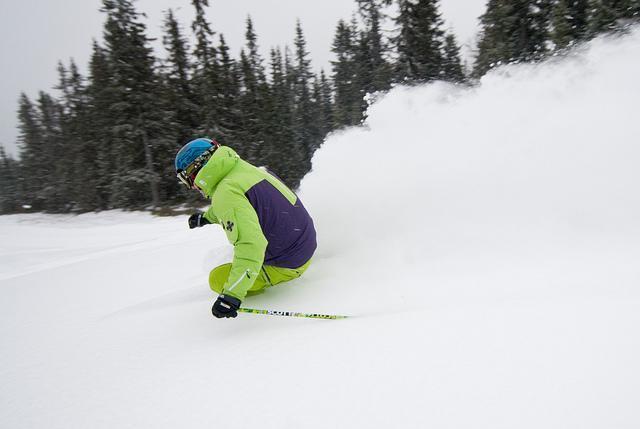How many horses are there?
Give a very brief answer. 0. 